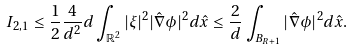<formula> <loc_0><loc_0><loc_500><loc_500>I _ { 2 , 1 } \leq \frac { 1 } { 2 } \frac { 4 } { d ^ { 2 } } d \int _ { \mathbb { R } ^ { 2 } } | \xi | ^ { 2 } | \hat { \nabla } \phi | ^ { 2 } d \hat { x } \leq \frac { 2 } { d } \int _ { B _ { R + 1 } } | \hat { \nabla } \phi | ^ { 2 } d \hat { x } .</formula> 